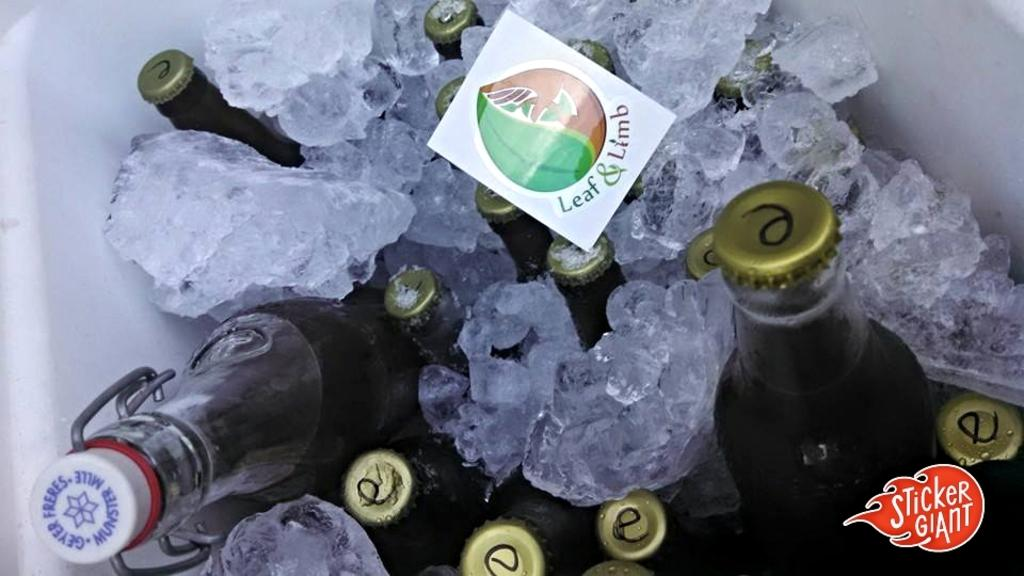<image>
Share a concise interpretation of the image provided. An inside of a cooler with ice and drinks and a note with the words leaf and limb 